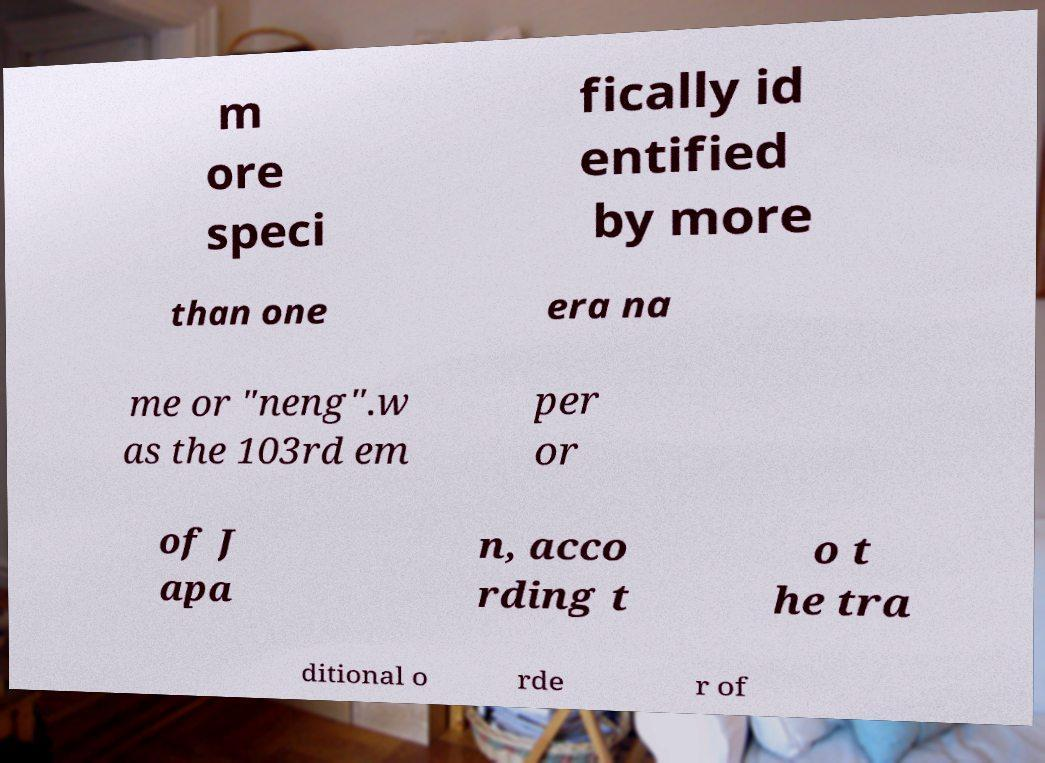Could you assist in decoding the text presented in this image and type it out clearly? m ore speci fically id entified by more than one era na me or "neng".w as the 103rd em per or of J apa n, acco rding t o t he tra ditional o rde r of 